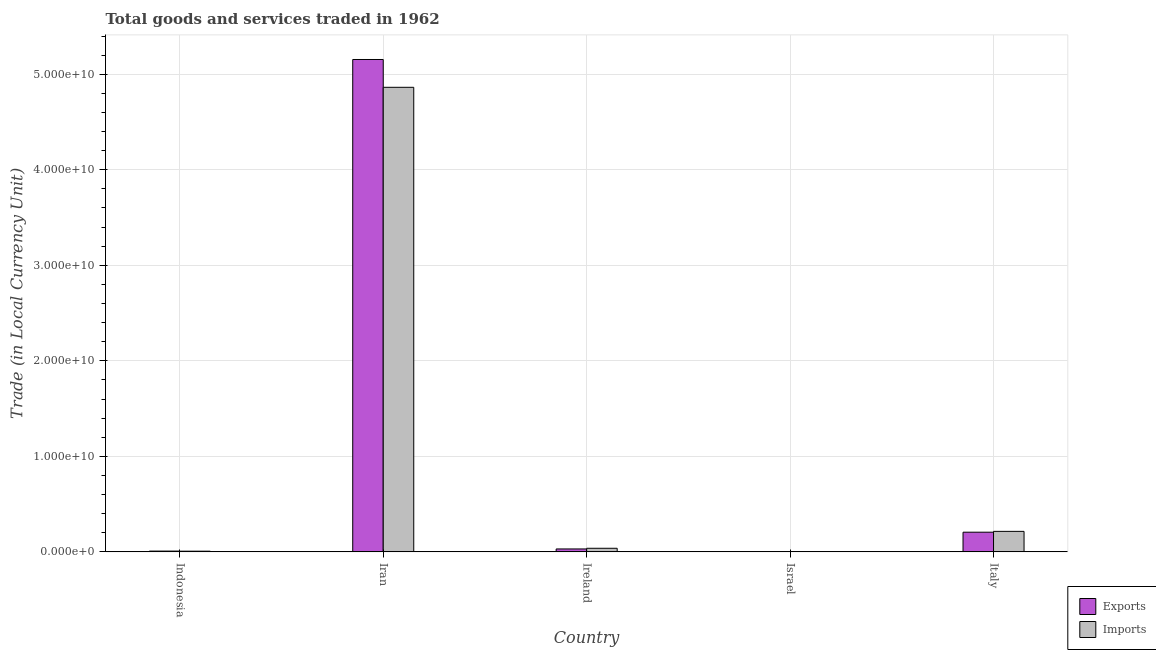How many different coloured bars are there?
Give a very brief answer. 2. How many groups of bars are there?
Give a very brief answer. 5. Are the number of bars per tick equal to the number of legend labels?
Your answer should be very brief. Yes. Are the number of bars on each tick of the X-axis equal?
Offer a terse response. Yes. How many bars are there on the 5th tick from the left?
Offer a very short reply. 2. How many bars are there on the 5th tick from the right?
Your answer should be compact. 2. In how many cases, is the number of bars for a given country not equal to the number of legend labels?
Provide a succinct answer. 0. What is the export of goods and services in Iran?
Ensure brevity in your answer.  5.15e+1. Across all countries, what is the maximum imports of goods and services?
Your answer should be very brief. 4.86e+1. Across all countries, what is the minimum imports of goods and services?
Offer a terse response. 1.26e+05. In which country was the export of goods and services maximum?
Provide a succinct answer. Iran. What is the total imports of goods and services in the graph?
Your answer should be very brief. 5.12e+1. What is the difference between the export of goods and services in Indonesia and that in Iran?
Make the answer very short. -5.15e+1. What is the difference between the imports of goods and services in Iran and the export of goods and services in Ireland?
Provide a succinct answer. 4.83e+1. What is the average imports of goods and services per country?
Provide a succinct answer. 1.02e+1. What is the difference between the export of goods and services and imports of goods and services in Indonesia?
Give a very brief answer. 9.90e+06. In how many countries, is the export of goods and services greater than 40000000000 LCU?
Your answer should be compact. 1. What is the ratio of the imports of goods and services in Ireland to that in Israel?
Offer a terse response. 2996.88. Is the imports of goods and services in Indonesia less than that in Ireland?
Your answer should be compact. Yes. Is the difference between the export of goods and services in Indonesia and Ireland greater than the difference between the imports of goods and services in Indonesia and Ireland?
Make the answer very short. Yes. What is the difference between the highest and the second highest imports of goods and services?
Give a very brief answer. 4.65e+1. What is the difference between the highest and the lowest imports of goods and services?
Make the answer very short. 4.86e+1. In how many countries, is the imports of goods and services greater than the average imports of goods and services taken over all countries?
Give a very brief answer. 1. Is the sum of the export of goods and services in Indonesia and Ireland greater than the maximum imports of goods and services across all countries?
Ensure brevity in your answer.  No. What does the 1st bar from the left in Italy represents?
Your answer should be very brief. Exports. What does the 2nd bar from the right in Italy represents?
Provide a short and direct response. Exports. How many countries are there in the graph?
Give a very brief answer. 5. What is the difference between two consecutive major ticks on the Y-axis?
Ensure brevity in your answer.  1.00e+1. Does the graph contain any zero values?
Your response must be concise. No. How many legend labels are there?
Provide a succinct answer. 2. How are the legend labels stacked?
Give a very brief answer. Vertical. What is the title of the graph?
Offer a terse response. Total goods and services traded in 1962. What is the label or title of the X-axis?
Your answer should be very brief. Country. What is the label or title of the Y-axis?
Make the answer very short. Trade (in Local Currency Unit). What is the Trade (in Local Currency Unit) in Exports in Indonesia?
Your response must be concise. 8.19e+07. What is the Trade (in Local Currency Unit) in Imports in Indonesia?
Your answer should be very brief. 7.20e+07. What is the Trade (in Local Currency Unit) of Exports in Iran?
Offer a terse response. 5.15e+1. What is the Trade (in Local Currency Unit) of Imports in Iran?
Offer a terse response. 4.86e+1. What is the Trade (in Local Currency Unit) in Exports in Ireland?
Your answer should be very brief. 3.07e+08. What is the Trade (in Local Currency Unit) in Imports in Ireland?
Give a very brief answer. 3.78e+08. What is the Trade (in Local Currency Unit) in Exports in Israel?
Your answer should be very brief. 1.34e+05. What is the Trade (in Local Currency Unit) of Imports in Israel?
Provide a succinct answer. 1.26e+05. What is the Trade (in Local Currency Unit) in Exports in Italy?
Your answer should be very brief. 2.06e+09. What is the Trade (in Local Currency Unit) in Imports in Italy?
Make the answer very short. 2.15e+09. Across all countries, what is the maximum Trade (in Local Currency Unit) in Exports?
Provide a short and direct response. 5.15e+1. Across all countries, what is the maximum Trade (in Local Currency Unit) in Imports?
Keep it short and to the point. 4.86e+1. Across all countries, what is the minimum Trade (in Local Currency Unit) of Exports?
Your answer should be very brief. 1.34e+05. Across all countries, what is the minimum Trade (in Local Currency Unit) in Imports?
Your answer should be very brief. 1.26e+05. What is the total Trade (in Local Currency Unit) in Exports in the graph?
Your response must be concise. 5.40e+1. What is the total Trade (in Local Currency Unit) of Imports in the graph?
Make the answer very short. 5.12e+1. What is the difference between the Trade (in Local Currency Unit) of Exports in Indonesia and that in Iran?
Your answer should be very brief. -5.15e+1. What is the difference between the Trade (in Local Currency Unit) of Imports in Indonesia and that in Iran?
Your answer should be very brief. -4.86e+1. What is the difference between the Trade (in Local Currency Unit) in Exports in Indonesia and that in Ireland?
Provide a short and direct response. -2.25e+08. What is the difference between the Trade (in Local Currency Unit) in Imports in Indonesia and that in Ireland?
Provide a short and direct response. -3.06e+08. What is the difference between the Trade (in Local Currency Unit) in Exports in Indonesia and that in Israel?
Offer a terse response. 8.18e+07. What is the difference between the Trade (in Local Currency Unit) in Imports in Indonesia and that in Israel?
Keep it short and to the point. 7.19e+07. What is the difference between the Trade (in Local Currency Unit) of Exports in Indonesia and that in Italy?
Make the answer very short. -1.98e+09. What is the difference between the Trade (in Local Currency Unit) of Imports in Indonesia and that in Italy?
Offer a very short reply. -2.08e+09. What is the difference between the Trade (in Local Currency Unit) in Exports in Iran and that in Ireland?
Offer a terse response. 5.12e+1. What is the difference between the Trade (in Local Currency Unit) of Imports in Iran and that in Ireland?
Ensure brevity in your answer.  4.83e+1. What is the difference between the Trade (in Local Currency Unit) of Exports in Iran and that in Israel?
Your response must be concise. 5.15e+1. What is the difference between the Trade (in Local Currency Unit) in Imports in Iran and that in Israel?
Offer a terse response. 4.86e+1. What is the difference between the Trade (in Local Currency Unit) of Exports in Iran and that in Italy?
Offer a terse response. 4.95e+1. What is the difference between the Trade (in Local Currency Unit) in Imports in Iran and that in Italy?
Your answer should be very brief. 4.65e+1. What is the difference between the Trade (in Local Currency Unit) of Exports in Ireland and that in Israel?
Give a very brief answer. 3.06e+08. What is the difference between the Trade (in Local Currency Unit) of Imports in Ireland and that in Israel?
Ensure brevity in your answer.  3.77e+08. What is the difference between the Trade (in Local Currency Unit) in Exports in Ireland and that in Italy?
Keep it short and to the point. -1.75e+09. What is the difference between the Trade (in Local Currency Unit) of Imports in Ireland and that in Italy?
Give a very brief answer. -1.77e+09. What is the difference between the Trade (in Local Currency Unit) in Exports in Israel and that in Italy?
Make the answer very short. -2.06e+09. What is the difference between the Trade (in Local Currency Unit) in Imports in Israel and that in Italy?
Give a very brief answer. -2.15e+09. What is the difference between the Trade (in Local Currency Unit) of Exports in Indonesia and the Trade (in Local Currency Unit) of Imports in Iran?
Provide a short and direct response. -4.86e+1. What is the difference between the Trade (in Local Currency Unit) of Exports in Indonesia and the Trade (in Local Currency Unit) of Imports in Ireland?
Give a very brief answer. -2.96e+08. What is the difference between the Trade (in Local Currency Unit) in Exports in Indonesia and the Trade (in Local Currency Unit) in Imports in Israel?
Keep it short and to the point. 8.18e+07. What is the difference between the Trade (in Local Currency Unit) in Exports in Indonesia and the Trade (in Local Currency Unit) in Imports in Italy?
Keep it short and to the point. -2.07e+09. What is the difference between the Trade (in Local Currency Unit) in Exports in Iran and the Trade (in Local Currency Unit) in Imports in Ireland?
Keep it short and to the point. 5.12e+1. What is the difference between the Trade (in Local Currency Unit) of Exports in Iran and the Trade (in Local Currency Unit) of Imports in Israel?
Ensure brevity in your answer.  5.15e+1. What is the difference between the Trade (in Local Currency Unit) of Exports in Iran and the Trade (in Local Currency Unit) of Imports in Italy?
Give a very brief answer. 4.94e+1. What is the difference between the Trade (in Local Currency Unit) of Exports in Ireland and the Trade (in Local Currency Unit) of Imports in Israel?
Offer a terse response. 3.06e+08. What is the difference between the Trade (in Local Currency Unit) of Exports in Ireland and the Trade (in Local Currency Unit) of Imports in Italy?
Provide a succinct answer. -1.84e+09. What is the difference between the Trade (in Local Currency Unit) in Exports in Israel and the Trade (in Local Currency Unit) in Imports in Italy?
Offer a terse response. -2.15e+09. What is the average Trade (in Local Currency Unit) in Exports per country?
Provide a succinct answer. 1.08e+1. What is the average Trade (in Local Currency Unit) in Imports per country?
Provide a short and direct response. 1.02e+1. What is the difference between the Trade (in Local Currency Unit) of Exports and Trade (in Local Currency Unit) of Imports in Indonesia?
Your answer should be compact. 9.90e+06. What is the difference between the Trade (in Local Currency Unit) in Exports and Trade (in Local Currency Unit) in Imports in Iran?
Offer a terse response. 2.91e+09. What is the difference between the Trade (in Local Currency Unit) of Exports and Trade (in Local Currency Unit) of Imports in Ireland?
Provide a short and direct response. -7.10e+07. What is the difference between the Trade (in Local Currency Unit) of Exports and Trade (in Local Currency Unit) of Imports in Israel?
Offer a very short reply. 8000. What is the difference between the Trade (in Local Currency Unit) in Exports and Trade (in Local Currency Unit) in Imports in Italy?
Keep it short and to the point. -8.69e+07. What is the ratio of the Trade (in Local Currency Unit) in Exports in Indonesia to that in Iran?
Provide a succinct answer. 0. What is the ratio of the Trade (in Local Currency Unit) of Imports in Indonesia to that in Iran?
Ensure brevity in your answer.  0. What is the ratio of the Trade (in Local Currency Unit) of Exports in Indonesia to that in Ireland?
Your answer should be compact. 0.27. What is the ratio of the Trade (in Local Currency Unit) in Imports in Indonesia to that in Ireland?
Provide a succinct answer. 0.19. What is the ratio of the Trade (in Local Currency Unit) in Exports in Indonesia to that in Israel?
Keep it short and to the point. 611.22. What is the ratio of the Trade (in Local Currency Unit) of Imports in Indonesia to that in Israel?
Make the answer very short. 571.43. What is the ratio of the Trade (in Local Currency Unit) in Exports in Indonesia to that in Italy?
Ensure brevity in your answer.  0.04. What is the ratio of the Trade (in Local Currency Unit) of Imports in Indonesia to that in Italy?
Make the answer very short. 0.03. What is the ratio of the Trade (in Local Currency Unit) of Exports in Iran to that in Ireland?
Offer a very short reply. 168.13. What is the ratio of the Trade (in Local Currency Unit) of Imports in Iran to that in Ireland?
Provide a succinct answer. 128.79. What is the ratio of the Trade (in Local Currency Unit) of Exports in Iran to that in Israel?
Provide a short and direct response. 3.85e+05. What is the ratio of the Trade (in Local Currency Unit) in Imports in Iran to that in Israel?
Your answer should be very brief. 3.86e+05. What is the ratio of the Trade (in Local Currency Unit) of Exports in Iran to that in Italy?
Provide a short and direct response. 25.01. What is the ratio of the Trade (in Local Currency Unit) of Imports in Iran to that in Italy?
Provide a succinct answer. 22.65. What is the ratio of the Trade (in Local Currency Unit) of Exports in Ireland to that in Israel?
Offer a terse response. 2287.81. What is the ratio of the Trade (in Local Currency Unit) of Imports in Ireland to that in Israel?
Offer a very short reply. 2996.88. What is the ratio of the Trade (in Local Currency Unit) in Exports in Ireland to that in Italy?
Your answer should be compact. 0.15. What is the ratio of the Trade (in Local Currency Unit) in Imports in Ireland to that in Italy?
Ensure brevity in your answer.  0.18. What is the ratio of the Trade (in Local Currency Unit) in Exports in Israel to that in Italy?
Offer a terse response. 0. What is the ratio of the Trade (in Local Currency Unit) of Imports in Israel to that in Italy?
Give a very brief answer. 0. What is the difference between the highest and the second highest Trade (in Local Currency Unit) in Exports?
Keep it short and to the point. 4.95e+1. What is the difference between the highest and the second highest Trade (in Local Currency Unit) of Imports?
Offer a very short reply. 4.65e+1. What is the difference between the highest and the lowest Trade (in Local Currency Unit) in Exports?
Provide a short and direct response. 5.15e+1. What is the difference between the highest and the lowest Trade (in Local Currency Unit) of Imports?
Offer a very short reply. 4.86e+1. 